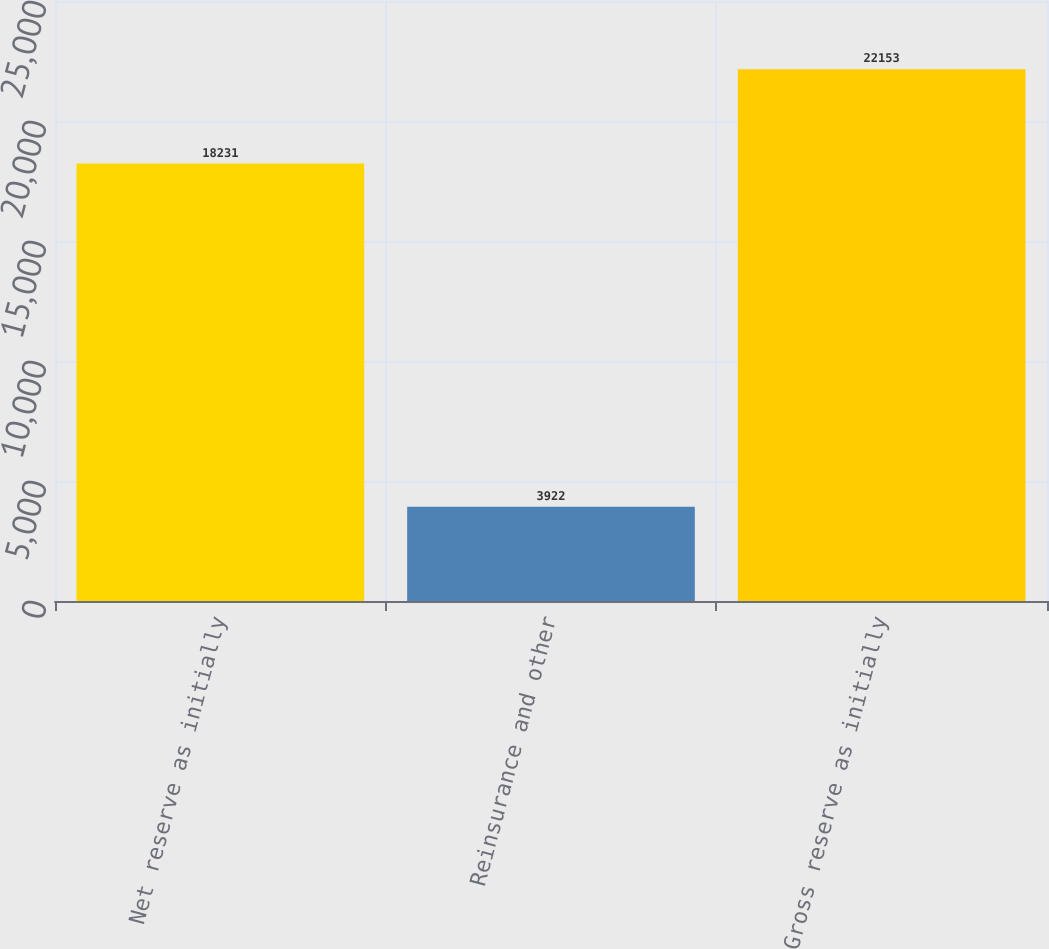Convert chart to OTSL. <chart><loc_0><loc_0><loc_500><loc_500><bar_chart><fcel>Net reserve as initially<fcel>Reinsurance and other<fcel>Gross reserve as initially<nl><fcel>18231<fcel>3922<fcel>22153<nl></chart> 